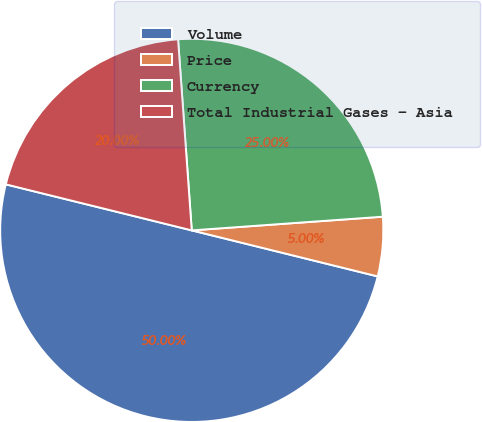Convert chart to OTSL. <chart><loc_0><loc_0><loc_500><loc_500><pie_chart><fcel>Volume<fcel>Price<fcel>Currency<fcel>Total Industrial Gases - Asia<nl><fcel>50.0%<fcel>5.0%<fcel>25.0%<fcel>20.0%<nl></chart> 